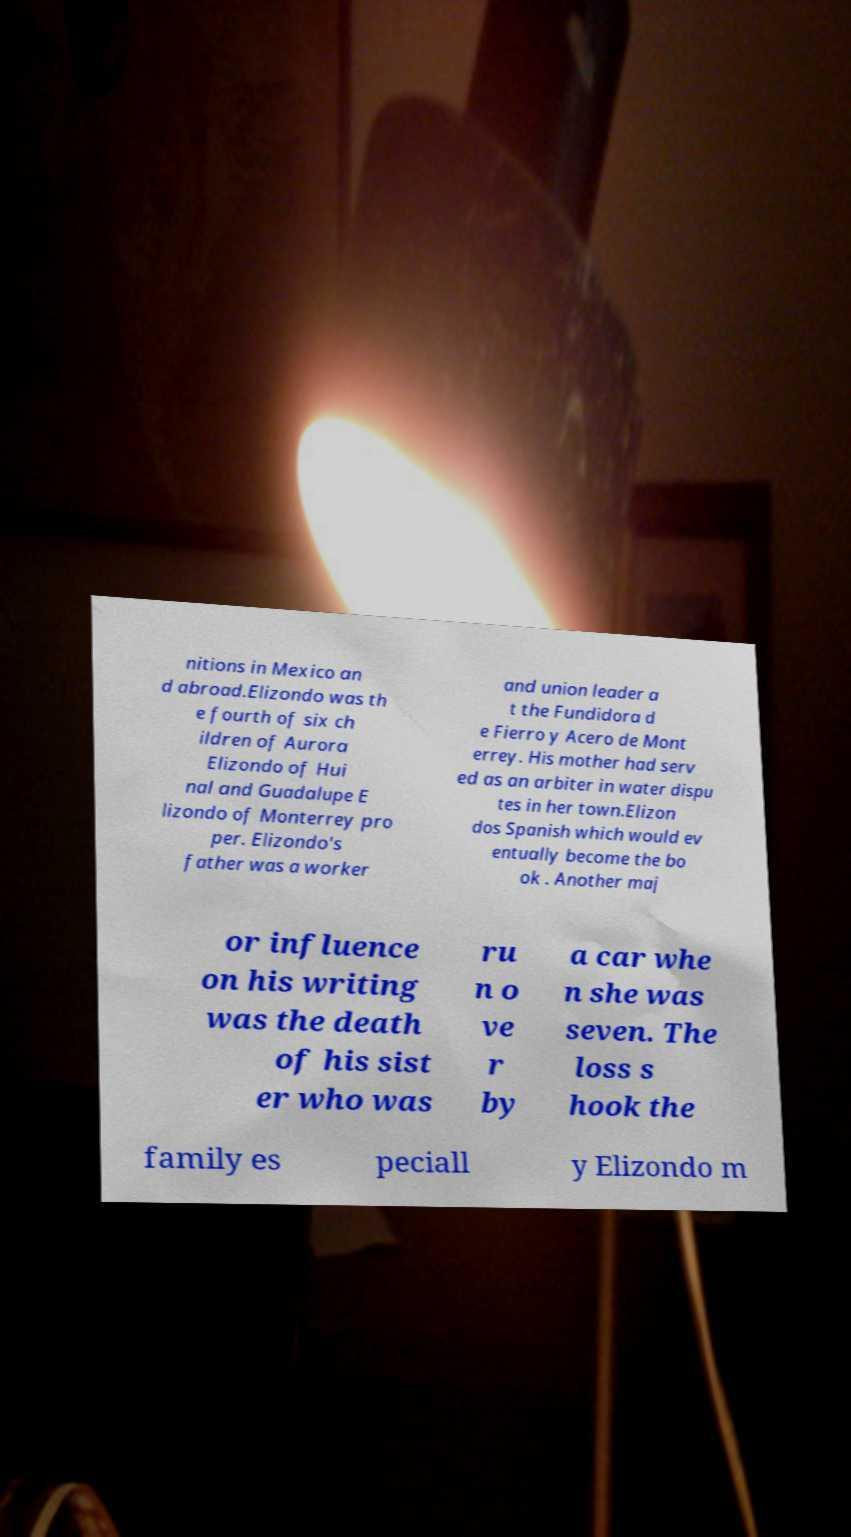I need the written content from this picture converted into text. Can you do that? nitions in Mexico an d abroad.Elizondo was th e fourth of six ch ildren of Aurora Elizondo of Hui nal and Guadalupe E lizondo of Monterrey pro per. Elizondo's father was a worker and union leader a t the Fundidora d e Fierro y Acero de Mont errey. His mother had serv ed as an arbiter in water dispu tes in her town.Elizon dos Spanish which would ev entually become the bo ok . Another maj or influence on his writing was the death of his sist er who was ru n o ve r by a car whe n she was seven. The loss s hook the family es peciall y Elizondo m 